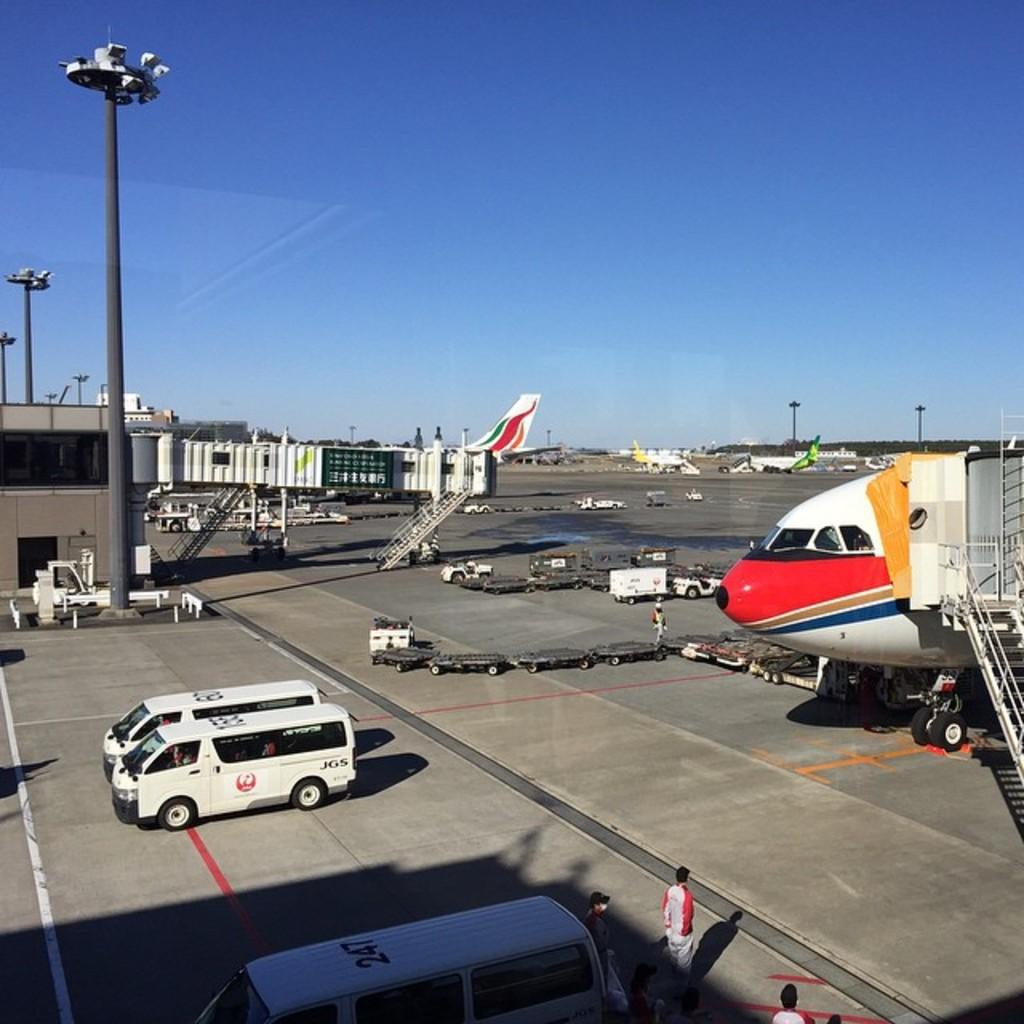Where was the image taken? The image was taken at an airport. What can be seen in the image besides the airport setting? There are aeroplanes, a runway, light poles, vehicles, persons, trees, and the sky visible in the image. What type of vehicles are present in the image? The specific type of vehicles cannot be determined from the image, but there are vehicles present. Can you describe the sky in the image? The sky is visible in the image, but no specific details about its appearance can be determined from the facts provided. What channel is the news broadcasting about spiders in the image? There is no news broadcast or mention of spiders in the image. 